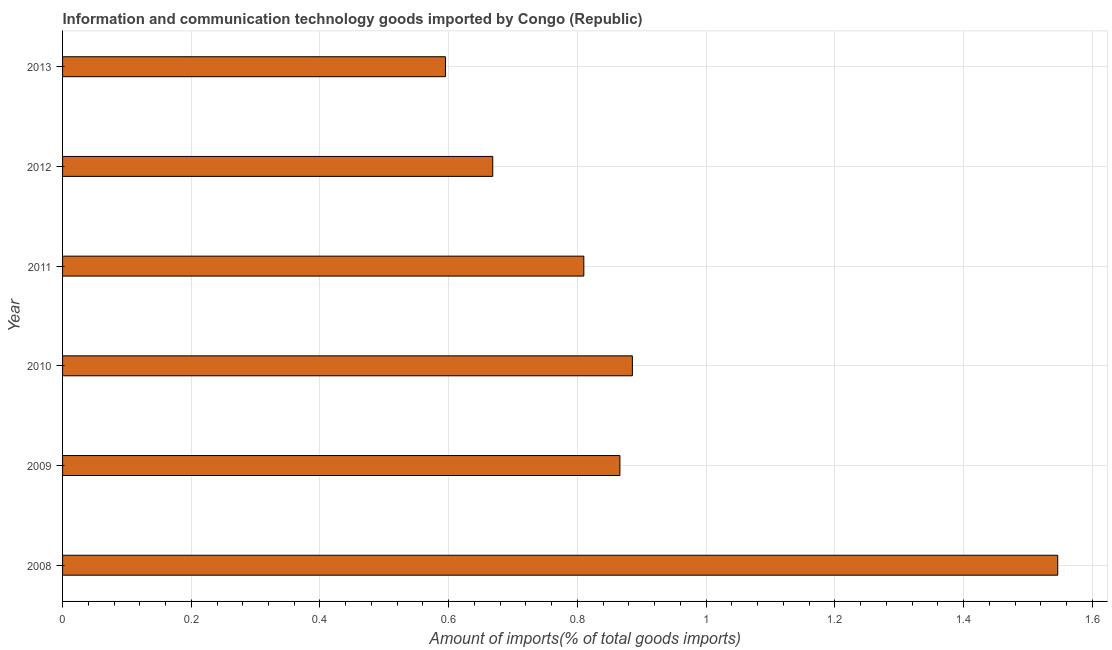Does the graph contain grids?
Offer a terse response. Yes. What is the title of the graph?
Ensure brevity in your answer.  Information and communication technology goods imported by Congo (Republic). What is the label or title of the X-axis?
Make the answer very short. Amount of imports(% of total goods imports). What is the amount of ict goods imports in 2013?
Your response must be concise. 0.59. Across all years, what is the maximum amount of ict goods imports?
Your response must be concise. 1.55. Across all years, what is the minimum amount of ict goods imports?
Make the answer very short. 0.59. In which year was the amount of ict goods imports minimum?
Provide a succinct answer. 2013. What is the sum of the amount of ict goods imports?
Make the answer very short. 5.37. What is the difference between the amount of ict goods imports in 2008 and 2012?
Give a very brief answer. 0.88. What is the average amount of ict goods imports per year?
Give a very brief answer. 0.9. What is the median amount of ict goods imports?
Make the answer very short. 0.84. In how many years, is the amount of ict goods imports greater than 0.84 %?
Your response must be concise. 3. What is the ratio of the amount of ict goods imports in 2012 to that in 2013?
Provide a succinct answer. 1.12. Is the amount of ict goods imports in 2011 less than that in 2012?
Keep it short and to the point. No. What is the difference between the highest and the second highest amount of ict goods imports?
Your answer should be compact. 0.66. What is the difference between the highest and the lowest amount of ict goods imports?
Keep it short and to the point. 0.95. Are all the bars in the graph horizontal?
Provide a succinct answer. Yes. What is the difference between two consecutive major ticks on the X-axis?
Your response must be concise. 0.2. What is the Amount of imports(% of total goods imports) in 2008?
Provide a succinct answer. 1.55. What is the Amount of imports(% of total goods imports) of 2009?
Your answer should be very brief. 0.87. What is the Amount of imports(% of total goods imports) in 2010?
Your response must be concise. 0.89. What is the Amount of imports(% of total goods imports) of 2011?
Give a very brief answer. 0.81. What is the Amount of imports(% of total goods imports) of 2012?
Make the answer very short. 0.67. What is the Amount of imports(% of total goods imports) of 2013?
Your answer should be very brief. 0.59. What is the difference between the Amount of imports(% of total goods imports) in 2008 and 2009?
Offer a terse response. 0.68. What is the difference between the Amount of imports(% of total goods imports) in 2008 and 2010?
Offer a terse response. 0.66. What is the difference between the Amount of imports(% of total goods imports) in 2008 and 2011?
Your answer should be compact. 0.74. What is the difference between the Amount of imports(% of total goods imports) in 2008 and 2012?
Provide a succinct answer. 0.88. What is the difference between the Amount of imports(% of total goods imports) in 2008 and 2013?
Make the answer very short. 0.95. What is the difference between the Amount of imports(% of total goods imports) in 2009 and 2010?
Offer a very short reply. -0.02. What is the difference between the Amount of imports(% of total goods imports) in 2009 and 2011?
Make the answer very short. 0.06. What is the difference between the Amount of imports(% of total goods imports) in 2009 and 2012?
Ensure brevity in your answer.  0.2. What is the difference between the Amount of imports(% of total goods imports) in 2009 and 2013?
Make the answer very short. 0.27. What is the difference between the Amount of imports(% of total goods imports) in 2010 and 2011?
Provide a short and direct response. 0.08. What is the difference between the Amount of imports(% of total goods imports) in 2010 and 2012?
Give a very brief answer. 0.22. What is the difference between the Amount of imports(% of total goods imports) in 2010 and 2013?
Provide a short and direct response. 0.29. What is the difference between the Amount of imports(% of total goods imports) in 2011 and 2012?
Provide a succinct answer. 0.14. What is the difference between the Amount of imports(% of total goods imports) in 2011 and 2013?
Make the answer very short. 0.22. What is the difference between the Amount of imports(% of total goods imports) in 2012 and 2013?
Keep it short and to the point. 0.07. What is the ratio of the Amount of imports(% of total goods imports) in 2008 to that in 2009?
Keep it short and to the point. 1.79. What is the ratio of the Amount of imports(% of total goods imports) in 2008 to that in 2010?
Ensure brevity in your answer.  1.75. What is the ratio of the Amount of imports(% of total goods imports) in 2008 to that in 2011?
Offer a very short reply. 1.91. What is the ratio of the Amount of imports(% of total goods imports) in 2008 to that in 2012?
Offer a terse response. 2.31. What is the ratio of the Amount of imports(% of total goods imports) in 2008 to that in 2013?
Offer a terse response. 2.6. What is the ratio of the Amount of imports(% of total goods imports) in 2009 to that in 2011?
Provide a succinct answer. 1.07. What is the ratio of the Amount of imports(% of total goods imports) in 2009 to that in 2012?
Provide a short and direct response. 1.3. What is the ratio of the Amount of imports(% of total goods imports) in 2009 to that in 2013?
Your answer should be very brief. 1.46. What is the ratio of the Amount of imports(% of total goods imports) in 2010 to that in 2011?
Ensure brevity in your answer.  1.09. What is the ratio of the Amount of imports(% of total goods imports) in 2010 to that in 2012?
Give a very brief answer. 1.32. What is the ratio of the Amount of imports(% of total goods imports) in 2010 to that in 2013?
Your answer should be compact. 1.49. What is the ratio of the Amount of imports(% of total goods imports) in 2011 to that in 2012?
Provide a succinct answer. 1.21. What is the ratio of the Amount of imports(% of total goods imports) in 2011 to that in 2013?
Keep it short and to the point. 1.36. What is the ratio of the Amount of imports(% of total goods imports) in 2012 to that in 2013?
Keep it short and to the point. 1.12. 